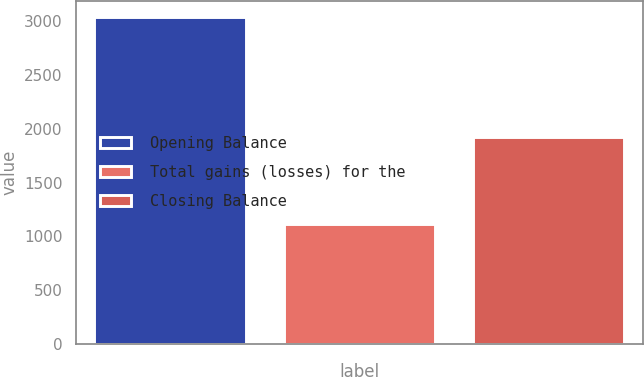Convert chart to OTSL. <chart><loc_0><loc_0><loc_500><loc_500><bar_chart><fcel>Opening Balance<fcel>Total gains (losses) for the<fcel>Closing Balance<nl><fcel>3041<fcel>1112<fcel>1929<nl></chart> 